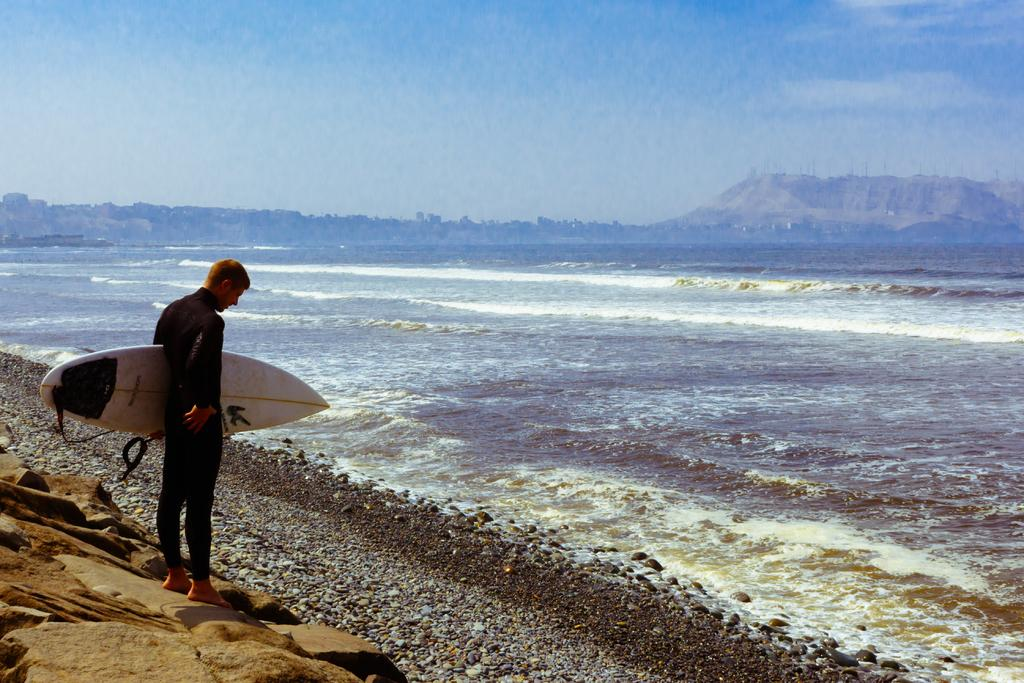Who is present in the image? There is a man in the image. What is the man holding in the image? The man is holding a board. What can be seen in the background of the image? Water and the sky are visible in the image. What type of plant can be seen growing in the garden in the image? There is no garden or plant present in the image. What type of flight is the man taking in the image? There is no flight or indication of travel in the image; the man is simply holding a board. 